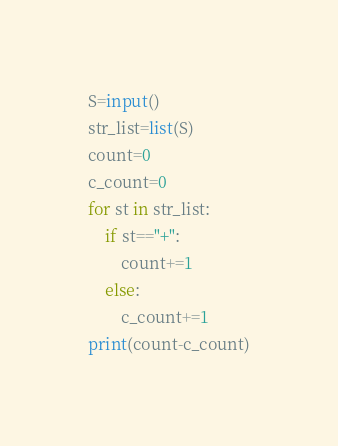Convert code to text. <code><loc_0><loc_0><loc_500><loc_500><_Python_>S=input()
str_list=list(S)
count=0
c_count=0
for st in str_list:
    if st=="+":
        count+=1
    else:
        c_count+=1
print(count-c_count)</code> 